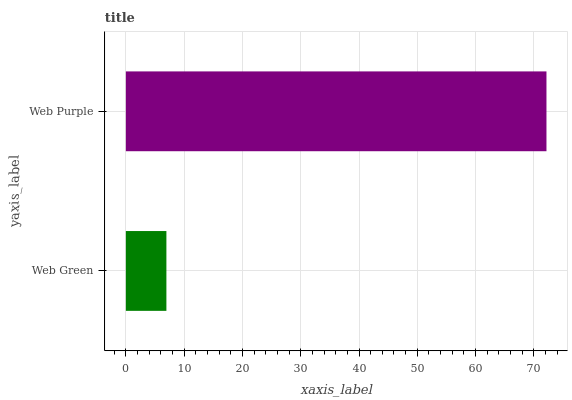Is Web Green the minimum?
Answer yes or no. Yes. Is Web Purple the maximum?
Answer yes or no. Yes. Is Web Purple the minimum?
Answer yes or no. No. Is Web Purple greater than Web Green?
Answer yes or no. Yes. Is Web Green less than Web Purple?
Answer yes or no. Yes. Is Web Green greater than Web Purple?
Answer yes or no. No. Is Web Purple less than Web Green?
Answer yes or no. No. Is Web Purple the high median?
Answer yes or no. Yes. Is Web Green the low median?
Answer yes or no. Yes. Is Web Green the high median?
Answer yes or no. No. Is Web Purple the low median?
Answer yes or no. No. 